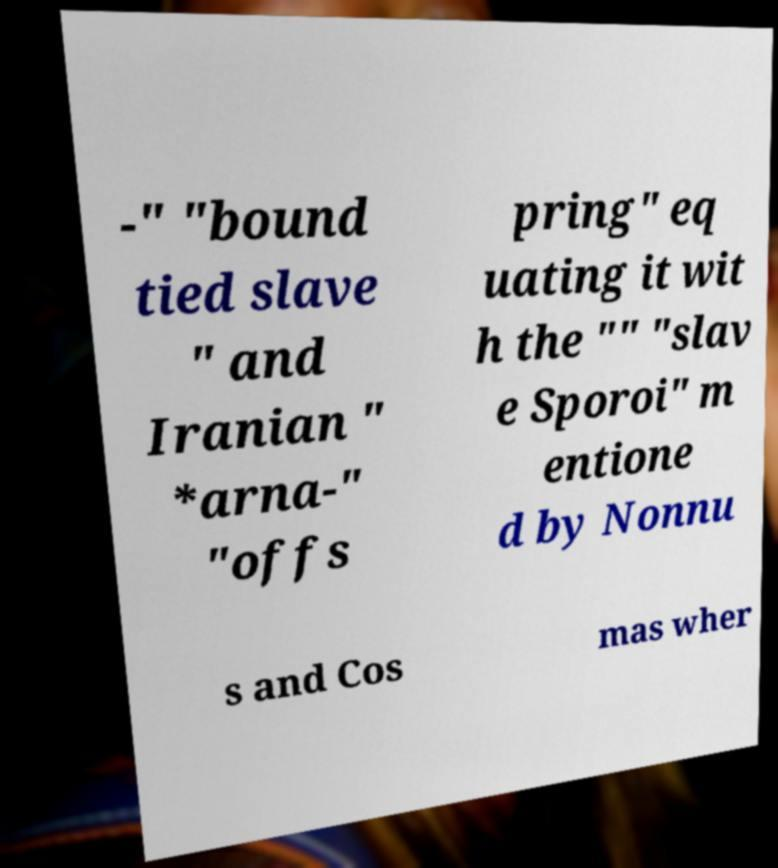Could you assist in decoding the text presented in this image and type it out clearly? -" "bound tied slave " and Iranian " *arna-" "offs pring" eq uating it wit h the "" "slav e Sporoi" m entione d by Nonnu s and Cos mas wher 